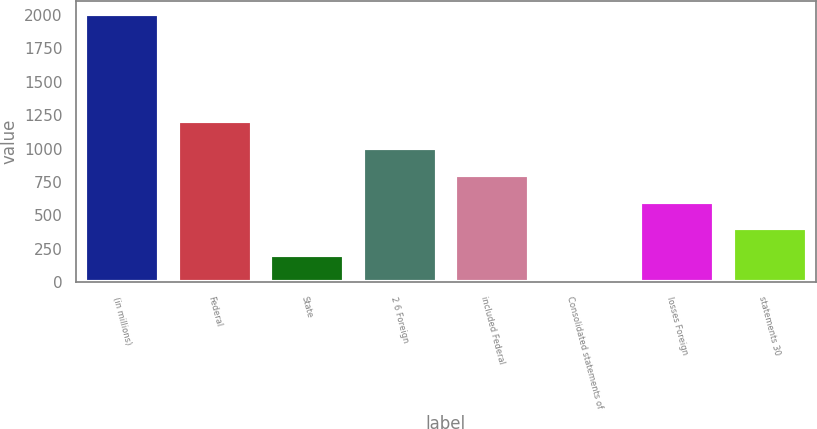Convert chart. <chart><loc_0><loc_0><loc_500><loc_500><bar_chart><fcel>(in millions)<fcel>Federal<fcel>State<fcel>2 6 Foreign<fcel>included Federal<fcel>Consolidated statements of<fcel>losses Foreign<fcel>statements 30<nl><fcel>2004<fcel>1204<fcel>204<fcel>1004<fcel>804<fcel>4<fcel>604<fcel>404<nl></chart> 